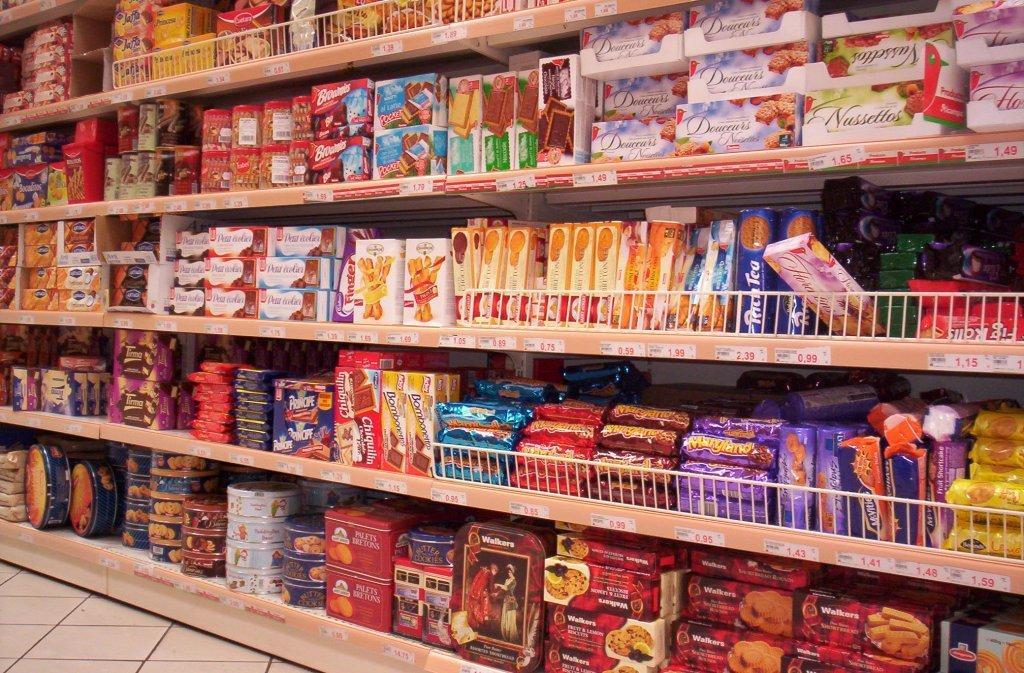In one or two sentences, can you explain what this image depicts? We can see boxes,jars and objects in racks. 